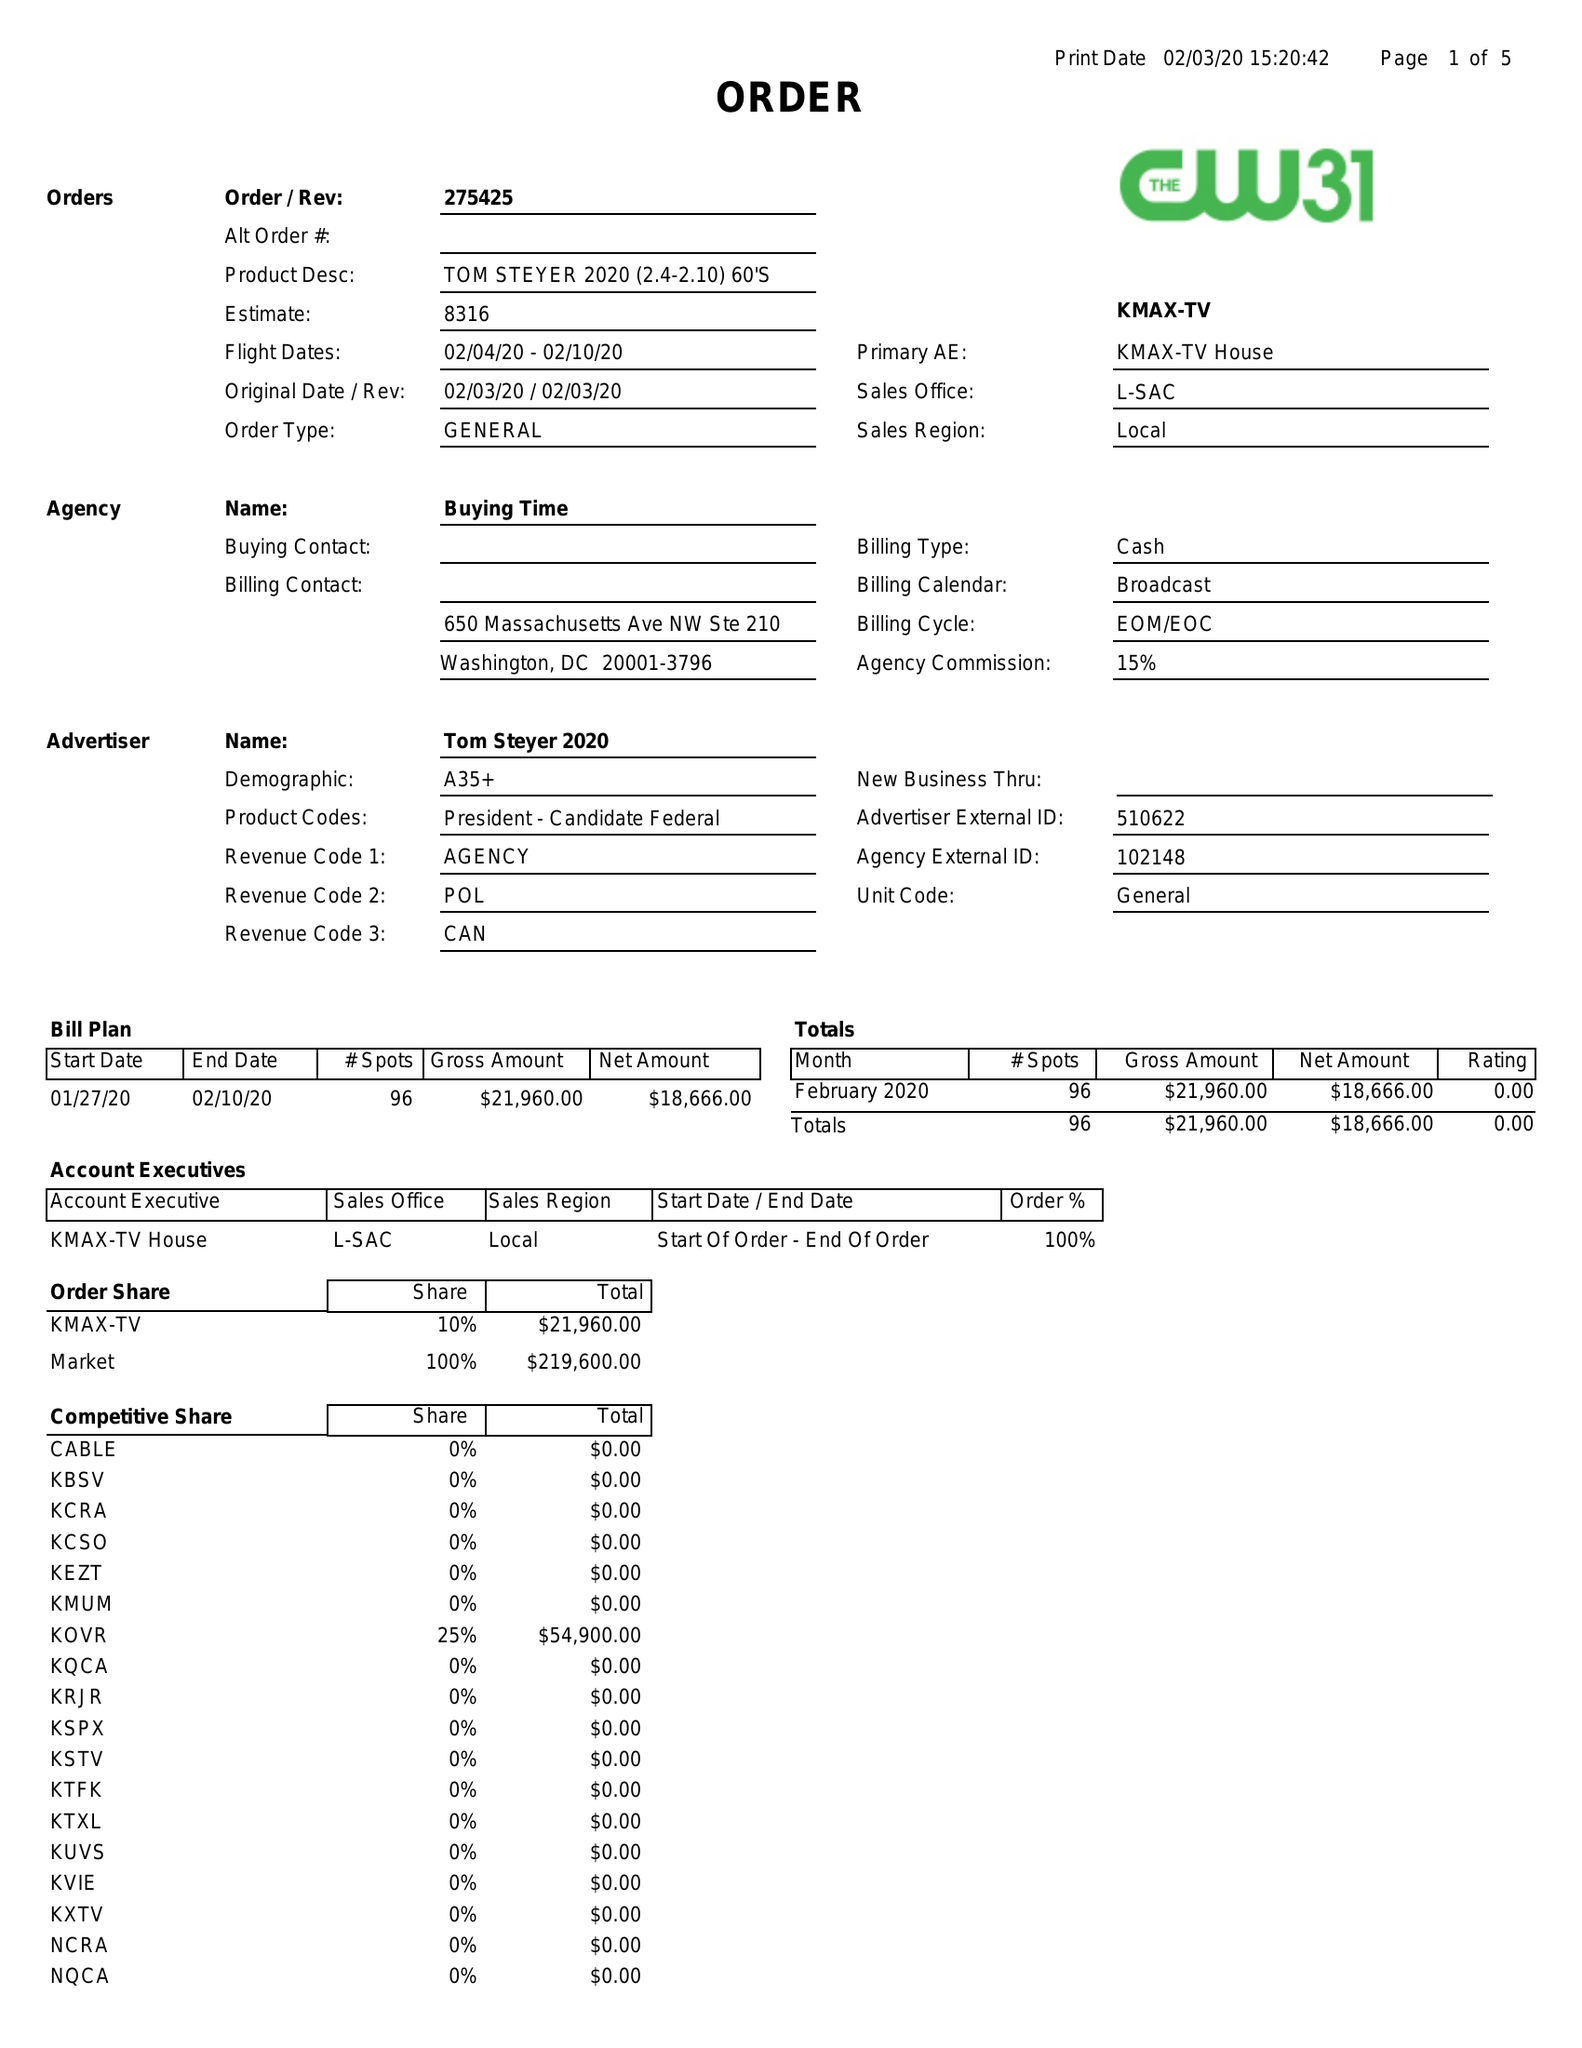What is the value for the advertiser?
Answer the question using a single word or phrase. TOM STEYER 2020 